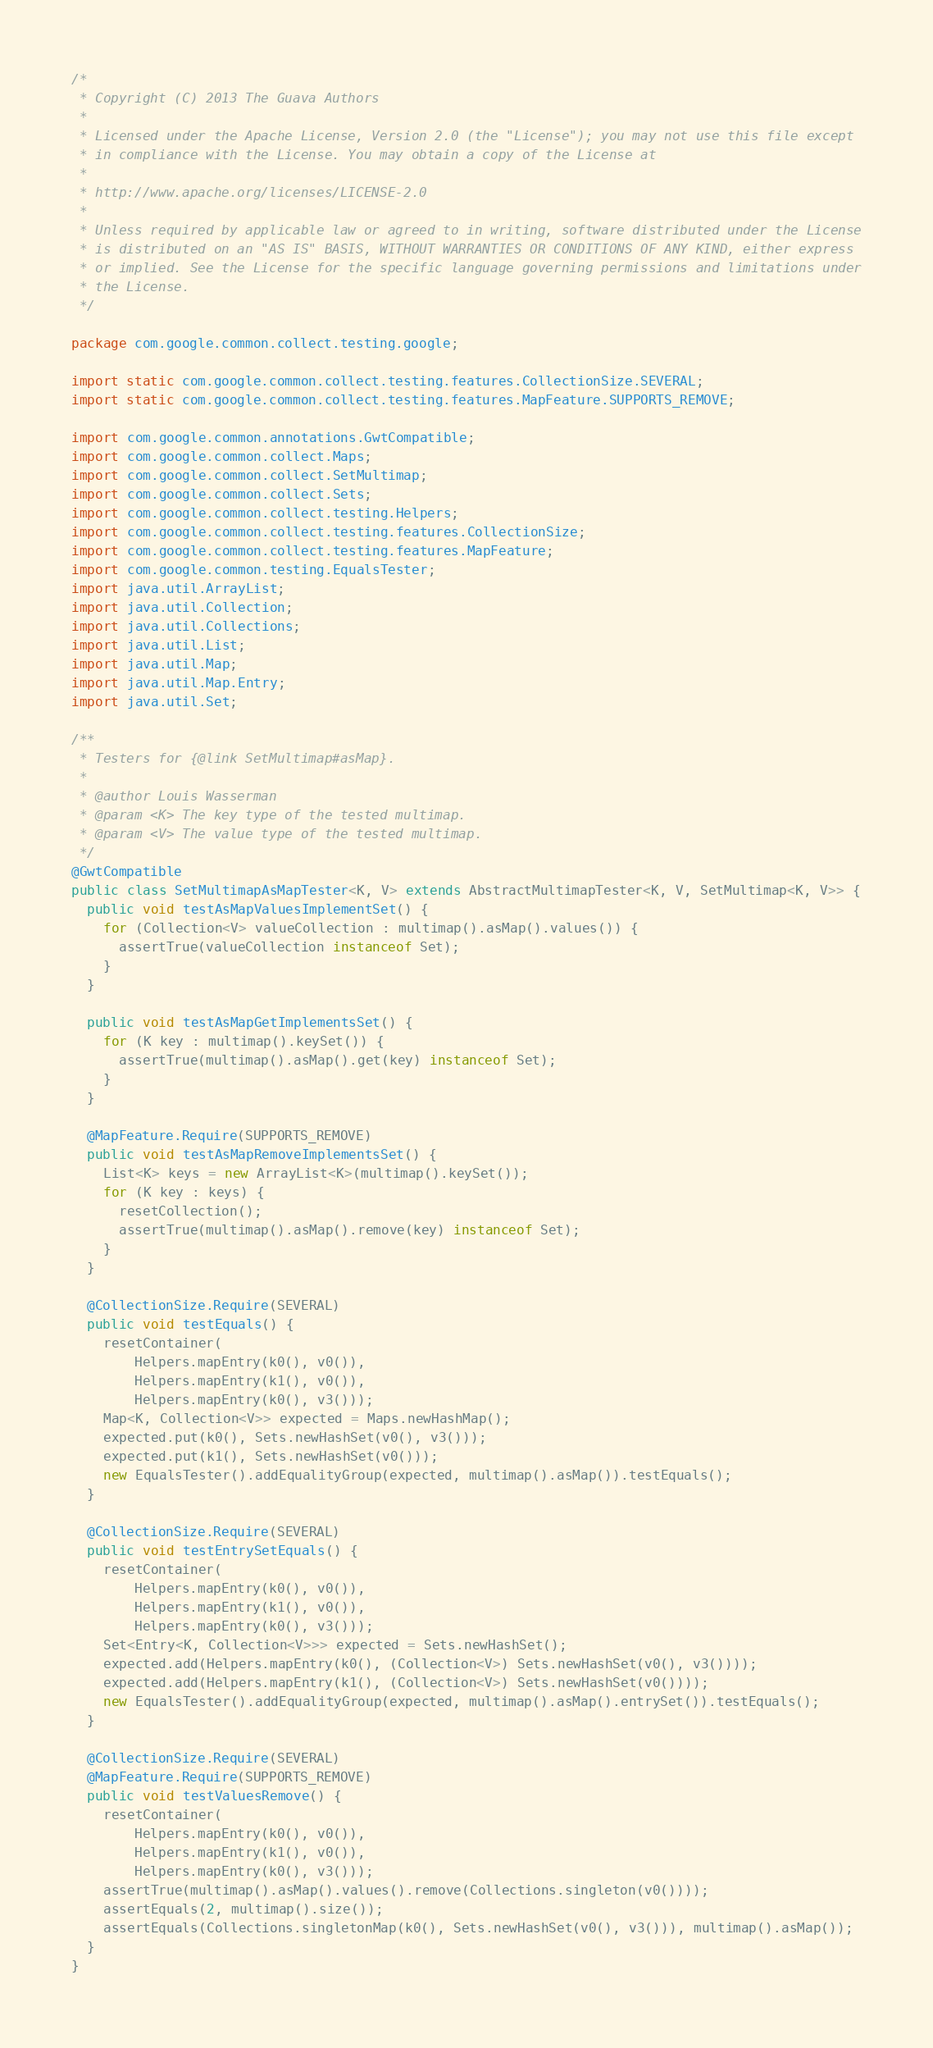<code> <loc_0><loc_0><loc_500><loc_500><_Java_>/*
 * Copyright (C) 2013 The Guava Authors
 *
 * Licensed under the Apache License, Version 2.0 (the "License"); you may not use this file except
 * in compliance with the License. You may obtain a copy of the License at
 *
 * http://www.apache.org/licenses/LICENSE-2.0
 *
 * Unless required by applicable law or agreed to in writing, software distributed under the License
 * is distributed on an "AS IS" BASIS, WITHOUT WARRANTIES OR CONDITIONS OF ANY KIND, either express
 * or implied. See the License for the specific language governing permissions and limitations under
 * the License.
 */

package com.google.common.collect.testing.google;

import static com.google.common.collect.testing.features.CollectionSize.SEVERAL;
import static com.google.common.collect.testing.features.MapFeature.SUPPORTS_REMOVE;

import com.google.common.annotations.GwtCompatible;
import com.google.common.collect.Maps;
import com.google.common.collect.SetMultimap;
import com.google.common.collect.Sets;
import com.google.common.collect.testing.Helpers;
import com.google.common.collect.testing.features.CollectionSize;
import com.google.common.collect.testing.features.MapFeature;
import com.google.common.testing.EqualsTester;
import java.util.ArrayList;
import java.util.Collection;
import java.util.Collections;
import java.util.List;
import java.util.Map;
import java.util.Map.Entry;
import java.util.Set;

/**
 * Testers for {@link SetMultimap#asMap}.
 *
 * @author Louis Wasserman
 * @param <K> The key type of the tested multimap.
 * @param <V> The value type of the tested multimap.
 */
@GwtCompatible
public class SetMultimapAsMapTester<K, V> extends AbstractMultimapTester<K, V, SetMultimap<K, V>> {
  public void testAsMapValuesImplementSet() {
    for (Collection<V> valueCollection : multimap().asMap().values()) {
      assertTrue(valueCollection instanceof Set);
    }
  }

  public void testAsMapGetImplementsSet() {
    for (K key : multimap().keySet()) {
      assertTrue(multimap().asMap().get(key) instanceof Set);
    }
  }

  @MapFeature.Require(SUPPORTS_REMOVE)
  public void testAsMapRemoveImplementsSet() {
    List<K> keys = new ArrayList<K>(multimap().keySet());
    for (K key : keys) {
      resetCollection();
      assertTrue(multimap().asMap().remove(key) instanceof Set);
    }
  }

  @CollectionSize.Require(SEVERAL)
  public void testEquals() {
    resetContainer(
        Helpers.mapEntry(k0(), v0()),
        Helpers.mapEntry(k1(), v0()),
        Helpers.mapEntry(k0(), v3()));
    Map<K, Collection<V>> expected = Maps.newHashMap();
    expected.put(k0(), Sets.newHashSet(v0(), v3()));
    expected.put(k1(), Sets.newHashSet(v0()));
    new EqualsTester().addEqualityGroup(expected, multimap().asMap()).testEquals();
  }

  @CollectionSize.Require(SEVERAL)
  public void testEntrySetEquals() {
    resetContainer(
        Helpers.mapEntry(k0(), v0()),
        Helpers.mapEntry(k1(), v0()),
        Helpers.mapEntry(k0(), v3()));
    Set<Entry<K, Collection<V>>> expected = Sets.newHashSet();
    expected.add(Helpers.mapEntry(k0(), (Collection<V>) Sets.newHashSet(v0(), v3())));
    expected.add(Helpers.mapEntry(k1(), (Collection<V>) Sets.newHashSet(v0())));
    new EqualsTester().addEqualityGroup(expected, multimap().asMap().entrySet()).testEquals();
  }

  @CollectionSize.Require(SEVERAL)
  @MapFeature.Require(SUPPORTS_REMOVE)
  public void testValuesRemove() {
    resetContainer(
        Helpers.mapEntry(k0(), v0()),
        Helpers.mapEntry(k1(), v0()),
        Helpers.mapEntry(k0(), v3()));
    assertTrue(multimap().asMap().values().remove(Collections.singleton(v0())));
    assertEquals(2, multimap().size());
    assertEquals(Collections.singletonMap(k0(), Sets.newHashSet(v0(), v3())), multimap().asMap());
  }
}
</code> 